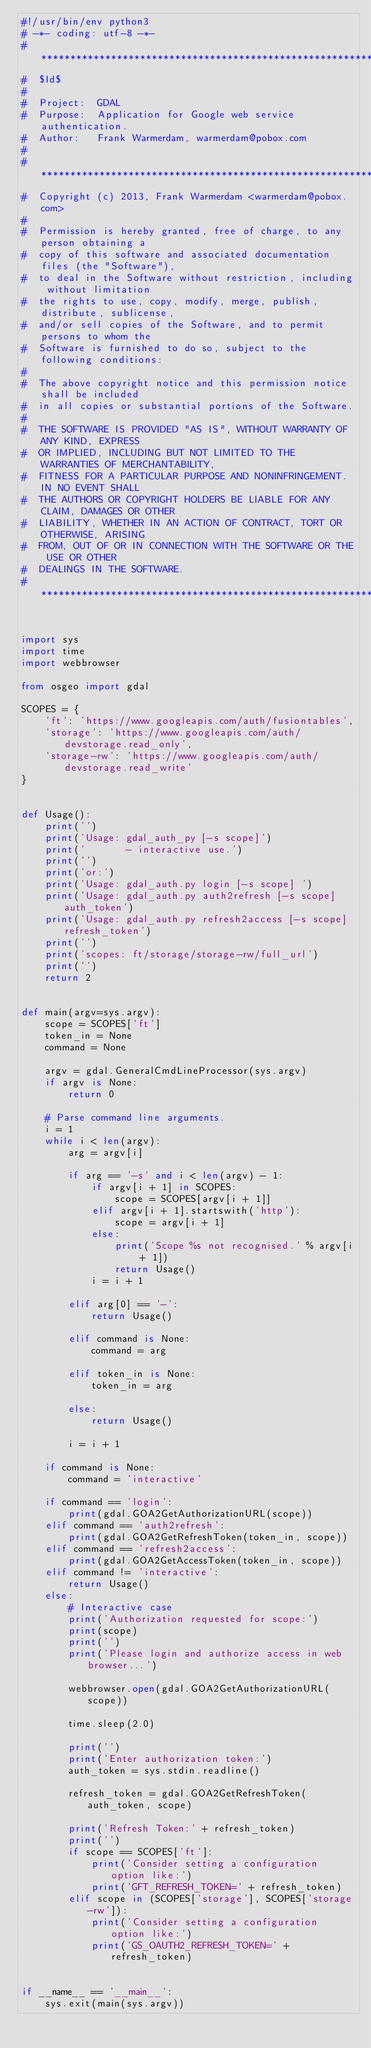<code> <loc_0><loc_0><loc_500><loc_500><_Python_>#!/usr/bin/env python3
# -*- coding: utf-8 -*-
# ******************************************************************************
#  $Id$
#
#  Project:  GDAL
#  Purpose:  Application for Google web service authentication.
#  Author:   Frank Warmerdam, warmerdam@pobox.com
#
# ******************************************************************************
#  Copyright (c) 2013, Frank Warmerdam <warmerdam@pobox.com>
#
#  Permission is hereby granted, free of charge, to any person obtaining a
#  copy of this software and associated documentation files (the "Software"),
#  to deal in the Software without restriction, including without limitation
#  the rights to use, copy, modify, merge, publish, distribute, sublicense,
#  and/or sell copies of the Software, and to permit persons to whom the
#  Software is furnished to do so, subject to the following conditions:
#
#  The above copyright notice and this permission notice shall be included
#  in all copies or substantial portions of the Software.
#
#  THE SOFTWARE IS PROVIDED "AS IS", WITHOUT WARRANTY OF ANY KIND, EXPRESS
#  OR IMPLIED, INCLUDING BUT NOT LIMITED TO THE WARRANTIES OF MERCHANTABILITY,
#  FITNESS FOR A PARTICULAR PURPOSE AND NONINFRINGEMENT. IN NO EVENT SHALL
#  THE AUTHORS OR COPYRIGHT HOLDERS BE LIABLE FOR ANY CLAIM, DAMAGES OR OTHER
#  LIABILITY, WHETHER IN AN ACTION OF CONTRACT, TORT OR OTHERWISE, ARISING
#  FROM, OUT OF OR IN CONNECTION WITH THE SOFTWARE OR THE USE OR OTHER
#  DEALINGS IN THE SOFTWARE.
# ******************************************************************************


import sys
import time
import webbrowser

from osgeo import gdal

SCOPES = {
    'ft': 'https://www.googleapis.com/auth/fusiontables',
    'storage': 'https://www.googleapis.com/auth/devstorage.read_only',
    'storage-rw': 'https://www.googleapis.com/auth/devstorage.read_write'
}


def Usage():
    print('')
    print('Usage: gdal_auth_py [-s scope]')
    print('       - interactive use.')
    print('')
    print('or:')
    print('Usage: gdal_auth.py login [-s scope] ')
    print('Usage: gdal_auth.py auth2refresh [-s scope] auth_token')
    print('Usage: gdal_auth.py refresh2access [-s scope] refresh_token')
    print('')
    print('scopes: ft/storage/storage-rw/full_url')
    print('')
    return 2


def main(argv=sys.argv):
    scope = SCOPES['ft']
    token_in = None
    command = None

    argv = gdal.GeneralCmdLineProcessor(sys.argv)
    if argv is None:
        return 0

    # Parse command line arguments.
    i = 1
    while i < len(argv):
        arg = argv[i]

        if arg == '-s' and i < len(argv) - 1:
            if argv[i + 1] in SCOPES:
                scope = SCOPES[argv[i + 1]]
            elif argv[i + 1].startswith('http'):
                scope = argv[i + 1]
            else:
                print('Scope %s not recognised.' % argv[i + 1])
                return Usage()
            i = i + 1

        elif arg[0] == '-':
            return Usage()

        elif command is None:
            command = arg

        elif token_in is None:
            token_in = arg

        else:
            return Usage()

        i = i + 1

    if command is None:
        command = 'interactive'

    if command == 'login':
        print(gdal.GOA2GetAuthorizationURL(scope))
    elif command == 'auth2refresh':
        print(gdal.GOA2GetRefreshToken(token_in, scope))
    elif command == 'refresh2access':
        print(gdal.GOA2GetAccessToken(token_in, scope))
    elif command != 'interactive':
        return Usage()
    else:
        # Interactive case
        print('Authorization requested for scope:')
        print(scope)
        print('')
        print('Please login and authorize access in web browser...')

        webbrowser.open(gdal.GOA2GetAuthorizationURL(scope))

        time.sleep(2.0)

        print('')
        print('Enter authorization token:')
        auth_token = sys.stdin.readline()

        refresh_token = gdal.GOA2GetRefreshToken(auth_token, scope)

        print('Refresh Token:' + refresh_token)
        print('')
        if scope == SCOPES['ft']:
            print('Consider setting a configuration option like:')
            print('GFT_REFRESH_TOKEN=' + refresh_token)
        elif scope in (SCOPES['storage'], SCOPES['storage-rw']):
            print('Consider setting a configuration option like:')
            print('GS_OAUTH2_REFRESH_TOKEN=' + refresh_token)


if __name__ == '__main__':
    sys.exit(main(sys.argv))
</code> 